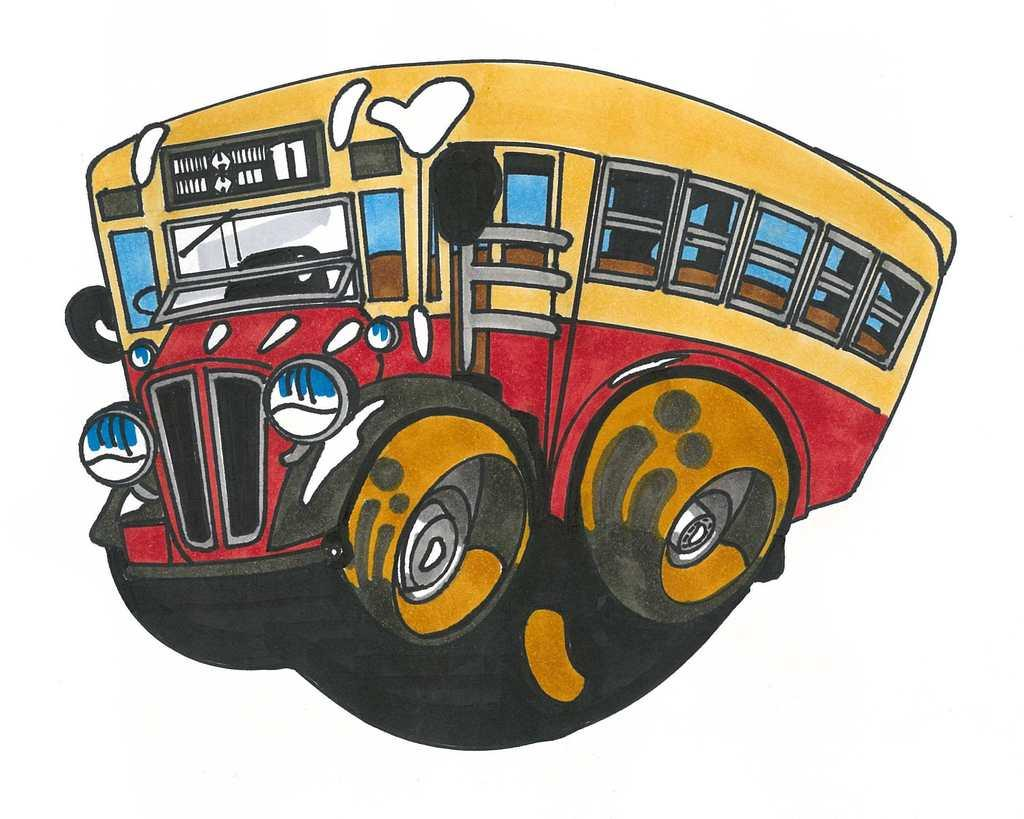What is the main subject of the picture? The main subject of the picture is a cartoon image of a vehicle. What color is the background of the image? The background color is white. How many dolls are sitting on the bridge in the image? There are no dolls or bridges present in the image; it features a cartoon image of a vehicle on a white background. 